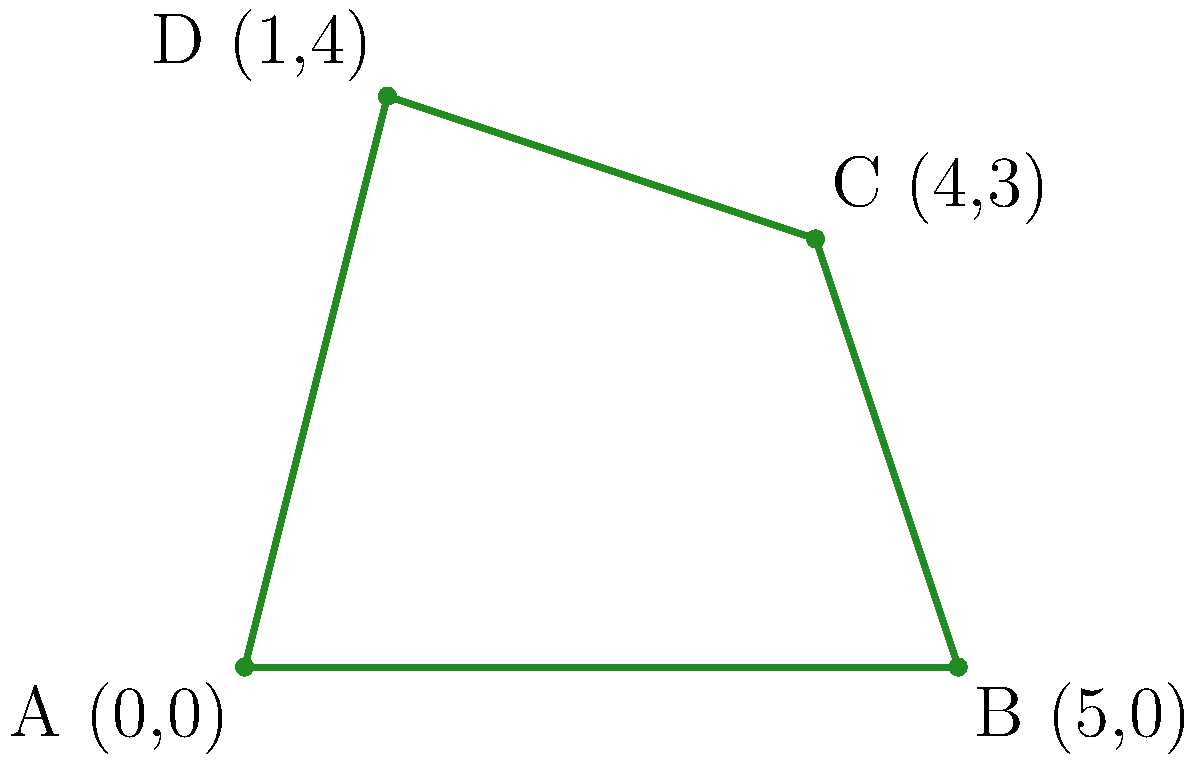As a forest ranger, you're tasked with calculating the perimeter of a protected wildlife area. The area is represented by a quadrilateral with corners at coordinates A(0,0), B(5,0), C(4,3), and D(1,4). Calculate the perimeter of this protected area to the nearest tenth of a unit. To calculate the perimeter, we need to find the distances between each consecutive pair of points and sum them up. We'll use the distance formula:

$d = \sqrt{(x_2-x_1)^2 + (y_2-y_1)^2}$

1. Distance AB:
   $AB = \sqrt{(5-0)^2 + (0-0)^2} = 5$

2. Distance BC:
   $BC = \sqrt{(4-5)^2 + (3-0)^2} = \sqrt{1^2 + 3^2} = \sqrt{10}$

3. Distance CD:
   $CD = \sqrt{(1-4)^2 + (4-3)^2} = \sqrt{(-3)^2 + 1^2} = \sqrt{10}$

4. Distance DA:
   $DA = \sqrt{(0-1)^2 + (0-4)^2} = \sqrt{1^2 + (-4)^2} = \sqrt{17}$

Now, let's sum up all these distances:

$\text{Perimeter} = AB + BC + CD + DA$
$= 5 + \sqrt{10} + \sqrt{10} + \sqrt{17}$
$= 5 + 2\sqrt{10} + \sqrt{17}$

Using a calculator and rounding to the nearest tenth:

$5 + 2(\sqrt{10}) + \sqrt{17} \approx 5 + 6.3 + 4.1 \approx 15.4$

Therefore, the perimeter of the protected wildlife area is approximately 15.4 units.
Answer: 15.4 units 